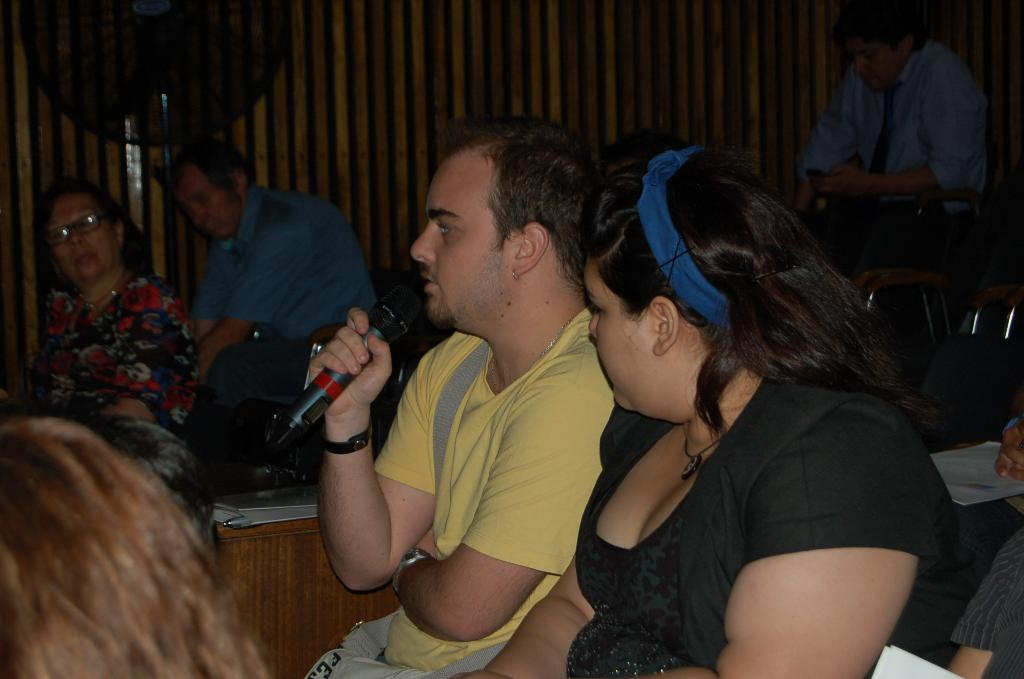What is the person in the image wearing? The person is wearing a yellow T-shirt. What is the person holding in their hands? The person is holding a mic in their hands. What can be seen in the background of the image? There are people sitting in the background of the image, and a wooden wall is visible. What color is the paint on the person's voice in the image? There is no paint mentioned in the image, and the person's voice is not visible. 